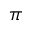<formula> <loc_0><loc_0><loc_500><loc_500>\pi</formula> 